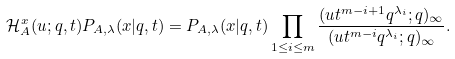Convert formula to latex. <formula><loc_0><loc_0><loc_500><loc_500>\mathcal { H } _ { A } ^ { x } ( u ; q , t ) P _ { A , \lambda } ( x | q , t ) = P _ { A , \lambda } ( x | q , t ) \prod _ { 1 \leq i \leq m } \frac { ( u t ^ { m - i + 1 } q ^ { \lambda _ { i } } ; q ) _ { \infty } } { ( u t ^ { m - i } q ^ { \lambda _ { i } } ; q ) _ { \infty } } .</formula> 